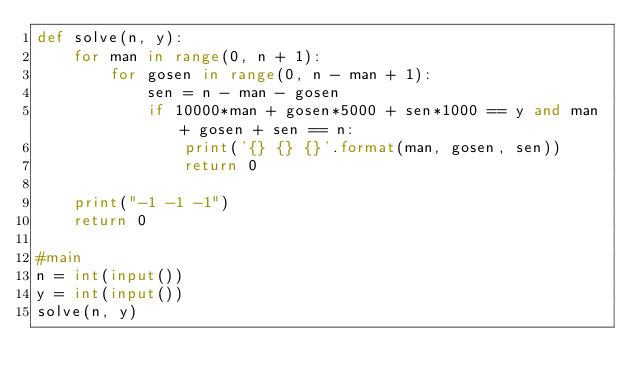<code> <loc_0><loc_0><loc_500><loc_500><_Python_>def solve(n, y):
    for man in range(0, n + 1):
        for gosen in range(0, n - man + 1):
            sen = n - man - gosen
            if 10000*man + gosen*5000 + sen*1000 == y and man + gosen + sen == n:
                print('{} {} {}'.format(man, gosen, sen))
                return 0

    print("-1 -1 -1")
    return 0            

#main
n = int(input())
y = int(input())
solve(n, y)


</code> 